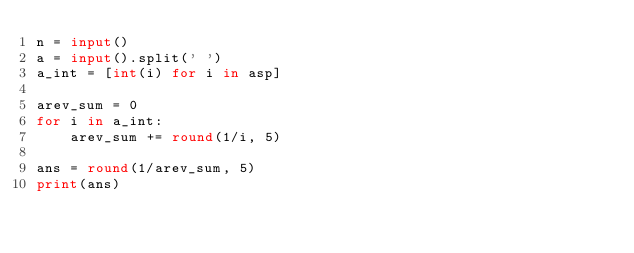<code> <loc_0><loc_0><loc_500><loc_500><_Python_>n = input()
a = input().split(' ')
a_int = [int(i) for i in asp]

arev_sum = 0
for i in a_int:
    arev_sum += round(1/i, 5)
    
ans = round(1/arev_sum, 5)
print(ans)</code> 